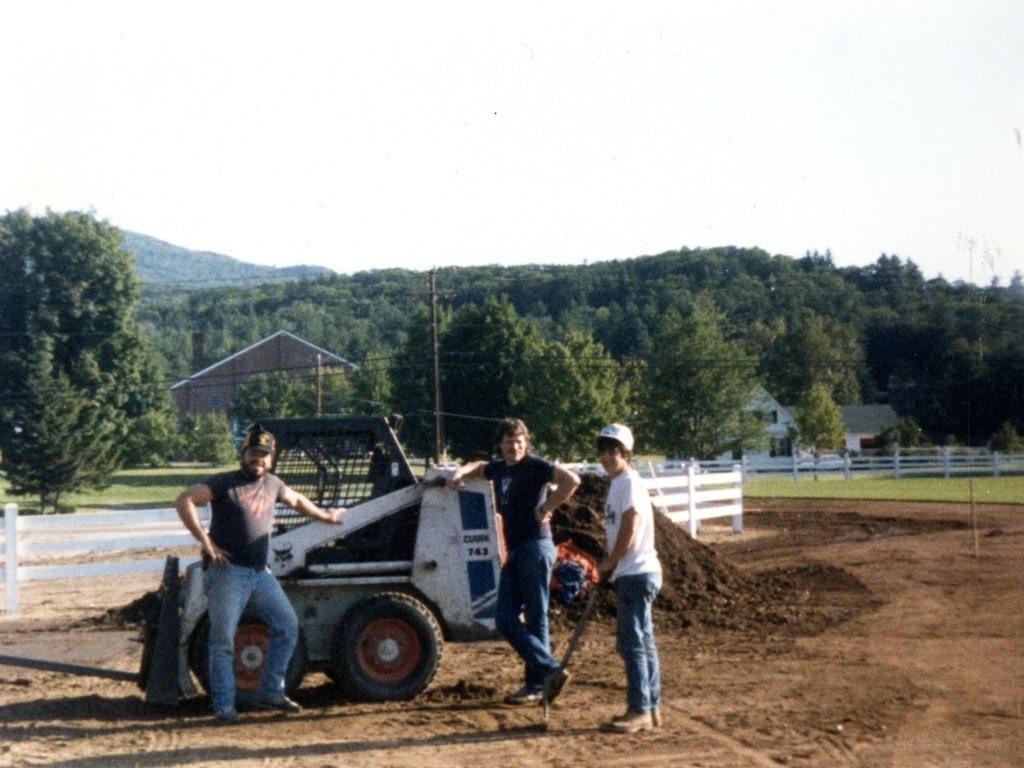Can you tell me more about the type of work these individuals might be doing? It's likely that the individuals are engaged in some form of earthmoving or construction work, given the chunks of soil visible and the skid steer loader they are using. This type of machinery is commonly utilized in tasks such as site preparation, debris removal, and other jobs that require heavy lifting and moving earth. The attire and body language of the individuals suggest they are well-acquainted with such tasks. 